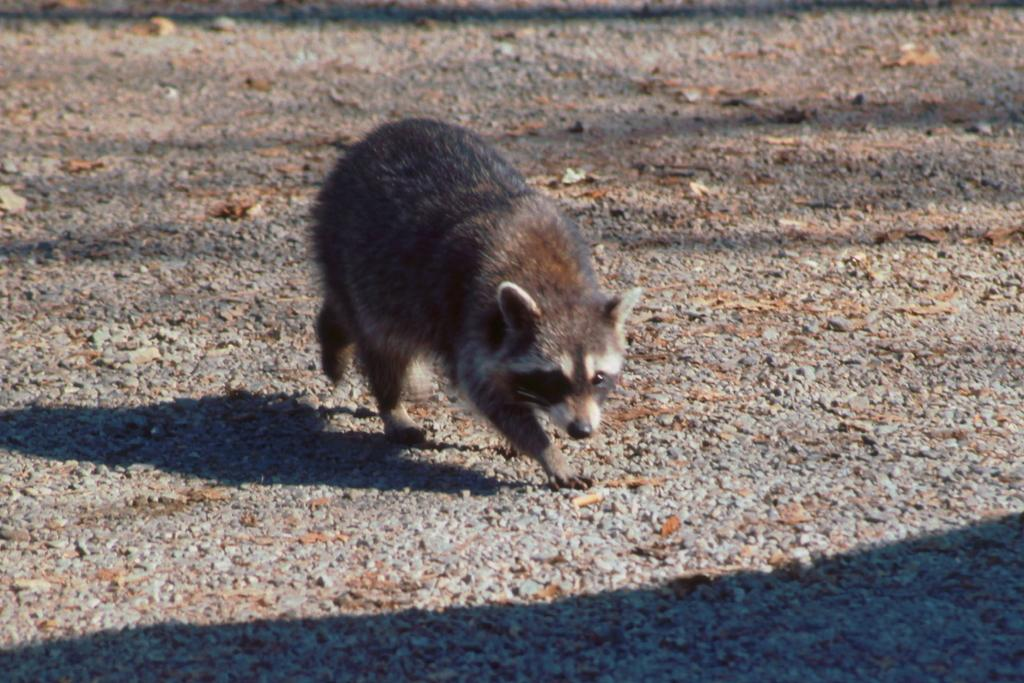What animal can be seen in the picture? There is a raccoon in the picture. What type of surface is visible at the bottom of the image? The pavement is visible at the bottom of the image. What natural elements are present at the bottom of the image? Dry leaves are present at the bottom of the image. Where can the shadow of the raccoon be seen in the image? The shadow of the raccoon is visible on the left side of the image. What type of bean is growing in the image? There are no beans present in the image; it features a raccoon, pavement, dry leaves, and a shadow. What historical event is depicted in the image? There is no historical event depicted in the image; it is a picture of a raccoon and its surroundings. 